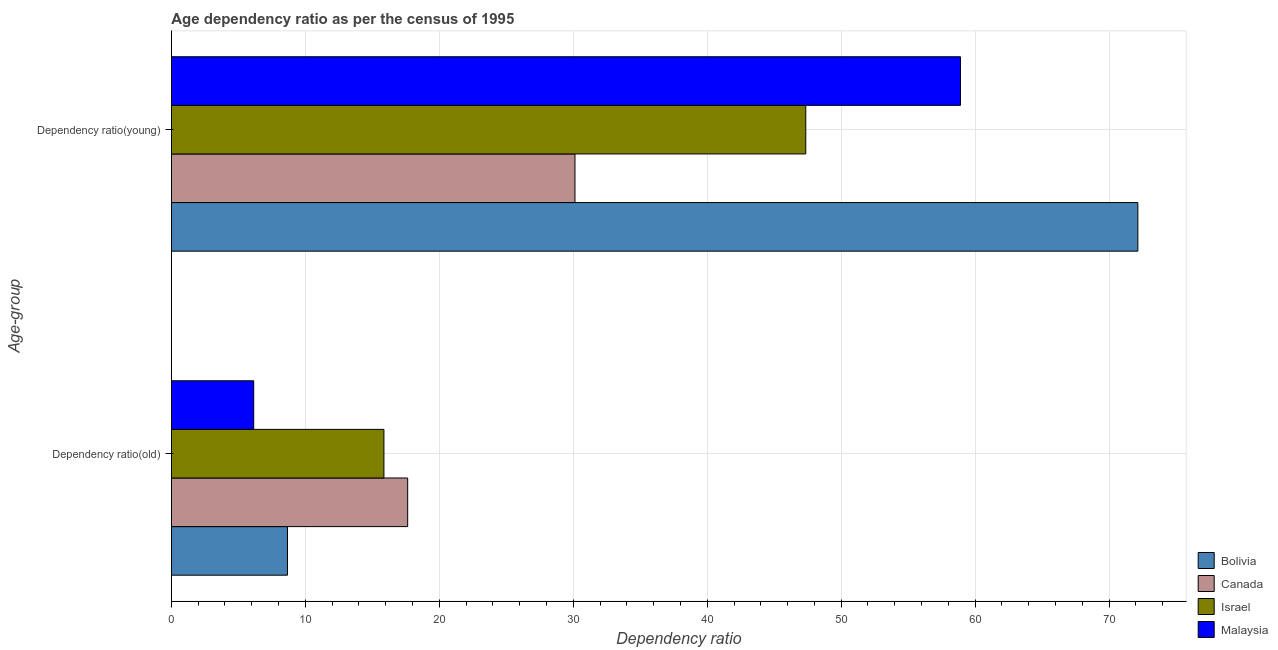How many different coloured bars are there?
Keep it short and to the point. 4. How many groups of bars are there?
Provide a short and direct response. 2. Are the number of bars per tick equal to the number of legend labels?
Keep it short and to the point. Yes. Are the number of bars on each tick of the Y-axis equal?
Make the answer very short. Yes. How many bars are there on the 1st tick from the top?
Ensure brevity in your answer.  4. What is the label of the 1st group of bars from the top?
Offer a very short reply. Dependency ratio(young). What is the age dependency ratio(old) in Canada?
Offer a very short reply. 17.64. Across all countries, what is the maximum age dependency ratio(old)?
Your answer should be very brief. 17.64. Across all countries, what is the minimum age dependency ratio(young)?
Provide a succinct answer. 30.13. In which country was the age dependency ratio(young) maximum?
Your answer should be compact. Bolivia. In which country was the age dependency ratio(young) minimum?
Provide a short and direct response. Canada. What is the total age dependency ratio(young) in the graph?
Give a very brief answer. 208.54. What is the difference between the age dependency ratio(old) in Malaysia and that in Canada?
Ensure brevity in your answer.  -11.49. What is the difference between the age dependency ratio(old) in Israel and the age dependency ratio(young) in Bolivia?
Keep it short and to the point. -56.28. What is the average age dependency ratio(old) per country?
Offer a very short reply. 12.08. What is the difference between the age dependency ratio(old) and age dependency ratio(young) in Bolivia?
Ensure brevity in your answer.  -63.48. In how many countries, is the age dependency ratio(old) greater than 62 ?
Provide a short and direct response. 0. What is the ratio of the age dependency ratio(young) in Israel to that in Malaysia?
Keep it short and to the point. 0.8. What does the 3rd bar from the bottom in Dependency ratio(old) represents?
Offer a very short reply. Israel. How many bars are there?
Keep it short and to the point. 8. Are all the bars in the graph horizontal?
Your answer should be compact. Yes. How many countries are there in the graph?
Your answer should be very brief. 4. What is the difference between two consecutive major ticks on the X-axis?
Keep it short and to the point. 10. Are the values on the major ticks of X-axis written in scientific E-notation?
Your answer should be compact. No. Where does the legend appear in the graph?
Give a very brief answer. Bottom right. What is the title of the graph?
Provide a short and direct response. Age dependency ratio as per the census of 1995. What is the label or title of the X-axis?
Provide a short and direct response. Dependency ratio. What is the label or title of the Y-axis?
Provide a succinct answer. Age-group. What is the Dependency ratio in Bolivia in Dependency ratio(old)?
Your answer should be very brief. 8.67. What is the Dependency ratio in Canada in Dependency ratio(old)?
Offer a terse response. 17.64. What is the Dependency ratio in Israel in Dependency ratio(old)?
Your answer should be very brief. 15.87. What is the Dependency ratio in Malaysia in Dependency ratio(old)?
Your answer should be compact. 6.15. What is the Dependency ratio in Bolivia in Dependency ratio(young)?
Your response must be concise. 72.15. What is the Dependency ratio of Canada in Dependency ratio(young)?
Your answer should be compact. 30.13. What is the Dependency ratio in Israel in Dependency ratio(young)?
Ensure brevity in your answer.  47.36. What is the Dependency ratio of Malaysia in Dependency ratio(young)?
Provide a short and direct response. 58.9. Across all Age-group, what is the maximum Dependency ratio of Bolivia?
Offer a very short reply. 72.15. Across all Age-group, what is the maximum Dependency ratio in Canada?
Provide a succinct answer. 30.13. Across all Age-group, what is the maximum Dependency ratio of Israel?
Ensure brevity in your answer.  47.36. Across all Age-group, what is the maximum Dependency ratio in Malaysia?
Give a very brief answer. 58.9. Across all Age-group, what is the minimum Dependency ratio in Bolivia?
Make the answer very short. 8.67. Across all Age-group, what is the minimum Dependency ratio in Canada?
Give a very brief answer. 17.64. Across all Age-group, what is the minimum Dependency ratio in Israel?
Your response must be concise. 15.87. Across all Age-group, what is the minimum Dependency ratio of Malaysia?
Provide a short and direct response. 6.15. What is the total Dependency ratio of Bolivia in the graph?
Offer a very short reply. 80.81. What is the total Dependency ratio in Canada in the graph?
Offer a terse response. 47.77. What is the total Dependency ratio of Israel in the graph?
Provide a succinct answer. 63.22. What is the total Dependency ratio of Malaysia in the graph?
Make the answer very short. 65.05. What is the difference between the Dependency ratio in Bolivia in Dependency ratio(old) and that in Dependency ratio(young)?
Make the answer very short. -63.48. What is the difference between the Dependency ratio in Canada in Dependency ratio(old) and that in Dependency ratio(young)?
Make the answer very short. -12.49. What is the difference between the Dependency ratio of Israel in Dependency ratio(old) and that in Dependency ratio(young)?
Offer a very short reply. -31.49. What is the difference between the Dependency ratio in Malaysia in Dependency ratio(old) and that in Dependency ratio(young)?
Provide a succinct answer. -52.76. What is the difference between the Dependency ratio in Bolivia in Dependency ratio(old) and the Dependency ratio in Canada in Dependency ratio(young)?
Make the answer very short. -21.46. What is the difference between the Dependency ratio of Bolivia in Dependency ratio(old) and the Dependency ratio of Israel in Dependency ratio(young)?
Your response must be concise. -38.69. What is the difference between the Dependency ratio of Bolivia in Dependency ratio(old) and the Dependency ratio of Malaysia in Dependency ratio(young)?
Ensure brevity in your answer.  -50.24. What is the difference between the Dependency ratio in Canada in Dependency ratio(old) and the Dependency ratio in Israel in Dependency ratio(young)?
Keep it short and to the point. -29.72. What is the difference between the Dependency ratio in Canada in Dependency ratio(old) and the Dependency ratio in Malaysia in Dependency ratio(young)?
Your response must be concise. -41.27. What is the difference between the Dependency ratio in Israel in Dependency ratio(old) and the Dependency ratio in Malaysia in Dependency ratio(young)?
Ensure brevity in your answer.  -43.04. What is the average Dependency ratio in Bolivia per Age-group?
Provide a short and direct response. 40.41. What is the average Dependency ratio of Canada per Age-group?
Your answer should be very brief. 23.88. What is the average Dependency ratio in Israel per Age-group?
Ensure brevity in your answer.  31.61. What is the average Dependency ratio of Malaysia per Age-group?
Provide a short and direct response. 32.52. What is the difference between the Dependency ratio of Bolivia and Dependency ratio of Canada in Dependency ratio(old)?
Provide a short and direct response. -8.97. What is the difference between the Dependency ratio of Bolivia and Dependency ratio of Israel in Dependency ratio(old)?
Your response must be concise. -7.2. What is the difference between the Dependency ratio in Bolivia and Dependency ratio in Malaysia in Dependency ratio(old)?
Your answer should be compact. 2.52. What is the difference between the Dependency ratio in Canada and Dependency ratio in Israel in Dependency ratio(old)?
Keep it short and to the point. 1.77. What is the difference between the Dependency ratio in Canada and Dependency ratio in Malaysia in Dependency ratio(old)?
Offer a terse response. 11.49. What is the difference between the Dependency ratio in Israel and Dependency ratio in Malaysia in Dependency ratio(old)?
Your response must be concise. 9.72. What is the difference between the Dependency ratio in Bolivia and Dependency ratio in Canada in Dependency ratio(young)?
Your answer should be very brief. 42.02. What is the difference between the Dependency ratio in Bolivia and Dependency ratio in Israel in Dependency ratio(young)?
Provide a succinct answer. 24.79. What is the difference between the Dependency ratio of Bolivia and Dependency ratio of Malaysia in Dependency ratio(young)?
Your answer should be compact. 13.24. What is the difference between the Dependency ratio in Canada and Dependency ratio in Israel in Dependency ratio(young)?
Your answer should be very brief. -17.23. What is the difference between the Dependency ratio in Canada and Dependency ratio in Malaysia in Dependency ratio(young)?
Your response must be concise. -28.78. What is the difference between the Dependency ratio in Israel and Dependency ratio in Malaysia in Dependency ratio(young)?
Offer a very short reply. -11.55. What is the ratio of the Dependency ratio in Bolivia in Dependency ratio(old) to that in Dependency ratio(young)?
Give a very brief answer. 0.12. What is the ratio of the Dependency ratio of Canada in Dependency ratio(old) to that in Dependency ratio(young)?
Offer a terse response. 0.59. What is the ratio of the Dependency ratio of Israel in Dependency ratio(old) to that in Dependency ratio(young)?
Keep it short and to the point. 0.34. What is the ratio of the Dependency ratio in Malaysia in Dependency ratio(old) to that in Dependency ratio(young)?
Give a very brief answer. 0.1. What is the difference between the highest and the second highest Dependency ratio of Bolivia?
Offer a terse response. 63.48. What is the difference between the highest and the second highest Dependency ratio of Canada?
Offer a terse response. 12.49. What is the difference between the highest and the second highest Dependency ratio of Israel?
Give a very brief answer. 31.49. What is the difference between the highest and the second highest Dependency ratio of Malaysia?
Offer a very short reply. 52.76. What is the difference between the highest and the lowest Dependency ratio in Bolivia?
Ensure brevity in your answer.  63.48. What is the difference between the highest and the lowest Dependency ratio of Canada?
Your answer should be very brief. 12.49. What is the difference between the highest and the lowest Dependency ratio in Israel?
Offer a very short reply. 31.49. What is the difference between the highest and the lowest Dependency ratio of Malaysia?
Provide a succinct answer. 52.76. 